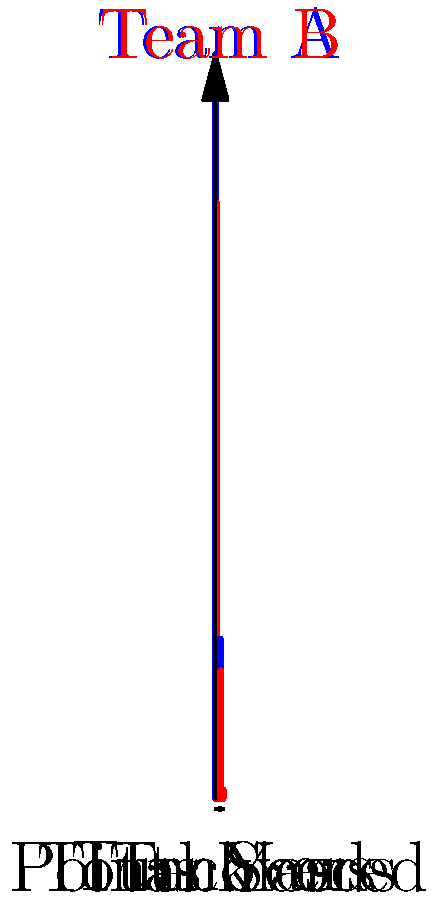Based on the bar chart comparing Team A and Team B's statistics, which team is more likely to win the upcoming game? To predict the game outcome, we need to analyze each statistic:

1. Total Yards: Team A has 350 yards vs. Team B's 280 yards. This gives Team A an advantage in offensive production.

2. Points Scored: Team B has scored 35 points vs. Team A's 28 points. This suggests Team B has been more efficient in converting yards to points.

3. Tackles: Team A has 75 tackles vs. Team B's 60. This indicates Team A's defense might be more active or facing more offensive plays.

4. Turnovers: Team B has 4 turnovers vs. Team A's 2. This is a significant disadvantage for Team B, as turnovers often lead to scoring opportunities for the opponent.

Weighing these factors:
- Team A has an advantage in total yards and fewer turnovers, which are crucial for maintaining possession and creating scoring opportunities.
- Team B has scored more points, but their higher turnover rate is concerning.

The deciding factor is likely the turnover differential. In football, protecting the ball is paramount, and Team A's ability to do so while generating more total yards gives them an edge.
Answer: Team A 